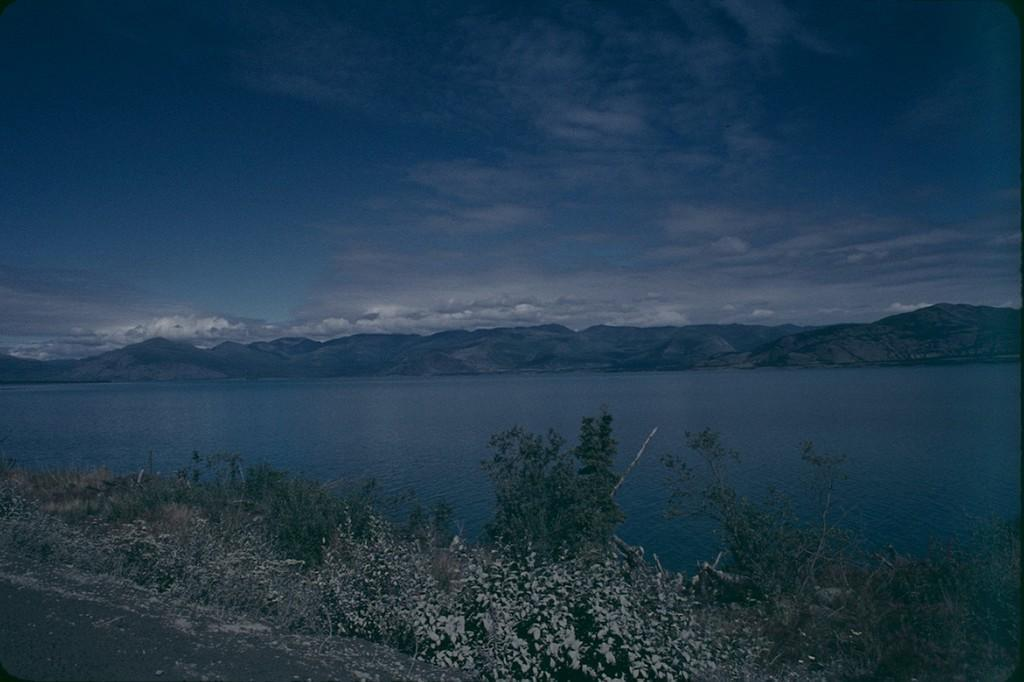What type of body of water is present in the image? There is a lake of water in the image. What else can be seen in the sky in the image? The sky is visible in the image. What type of vegetation is present in the image? There is grass in the image. Where is the bean located in the image? There is no bean present in the image. Can you tell me how tall the grandfather is in the image? There is no grandfather present in the image. 